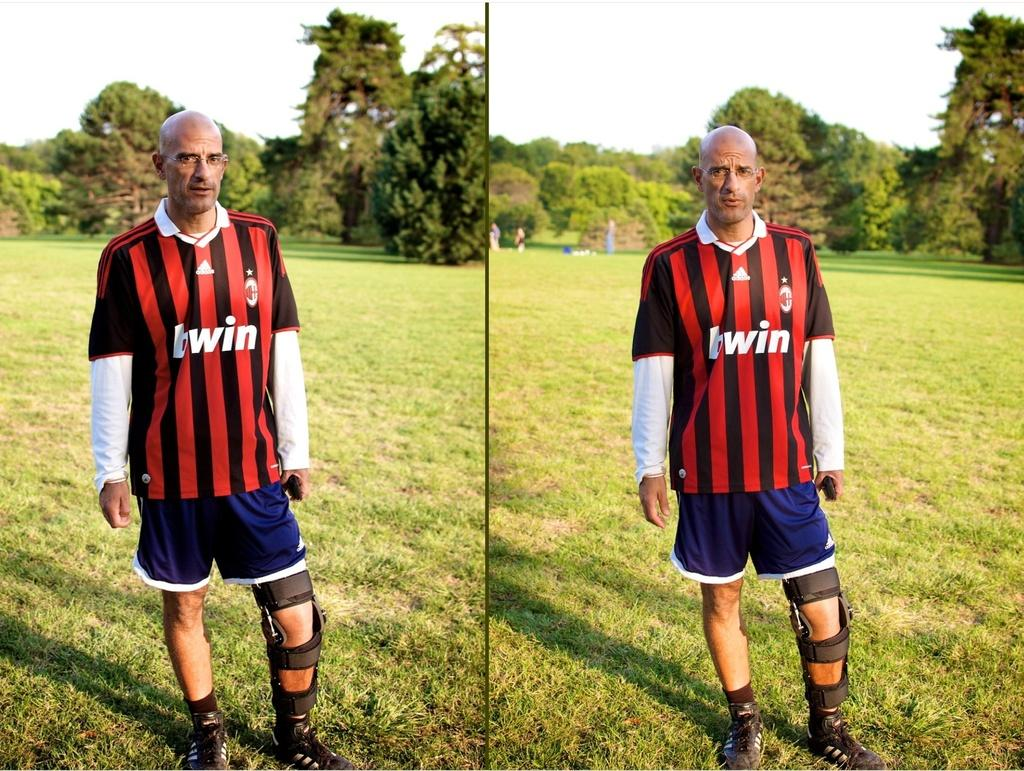Provide a one-sentence caption for the provided image. A man wears a striped shirt that has twin on the front. 